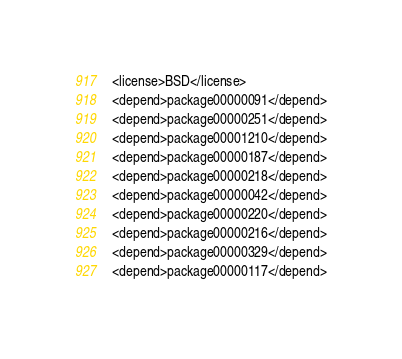<code> <loc_0><loc_0><loc_500><loc_500><_XML_>  <license>BSD</license>
  <depend>package00000091</depend>
  <depend>package00000251</depend>
  <depend>package00001210</depend>
  <depend>package00000187</depend>
  <depend>package00000218</depend>
  <depend>package00000042</depend>
  <depend>package00000220</depend>
  <depend>package00000216</depend>
  <depend>package00000329</depend>
  <depend>package00000117</depend></code> 